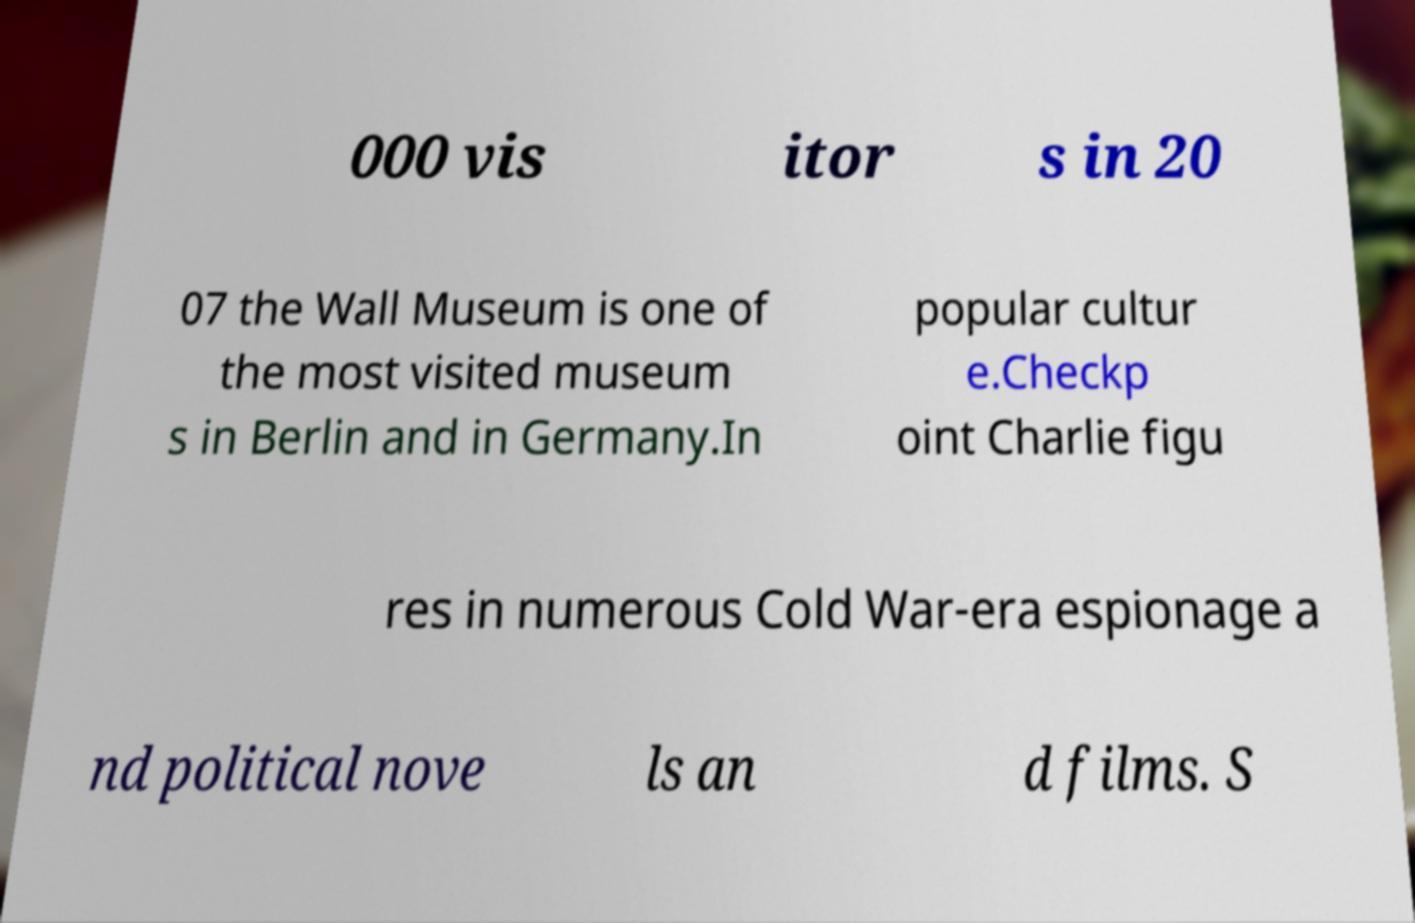Could you extract and type out the text from this image? 000 vis itor s in 20 07 the Wall Museum is one of the most visited museum s in Berlin and in Germany.In popular cultur e.Checkp oint Charlie figu res in numerous Cold War-era espionage a nd political nove ls an d films. S 